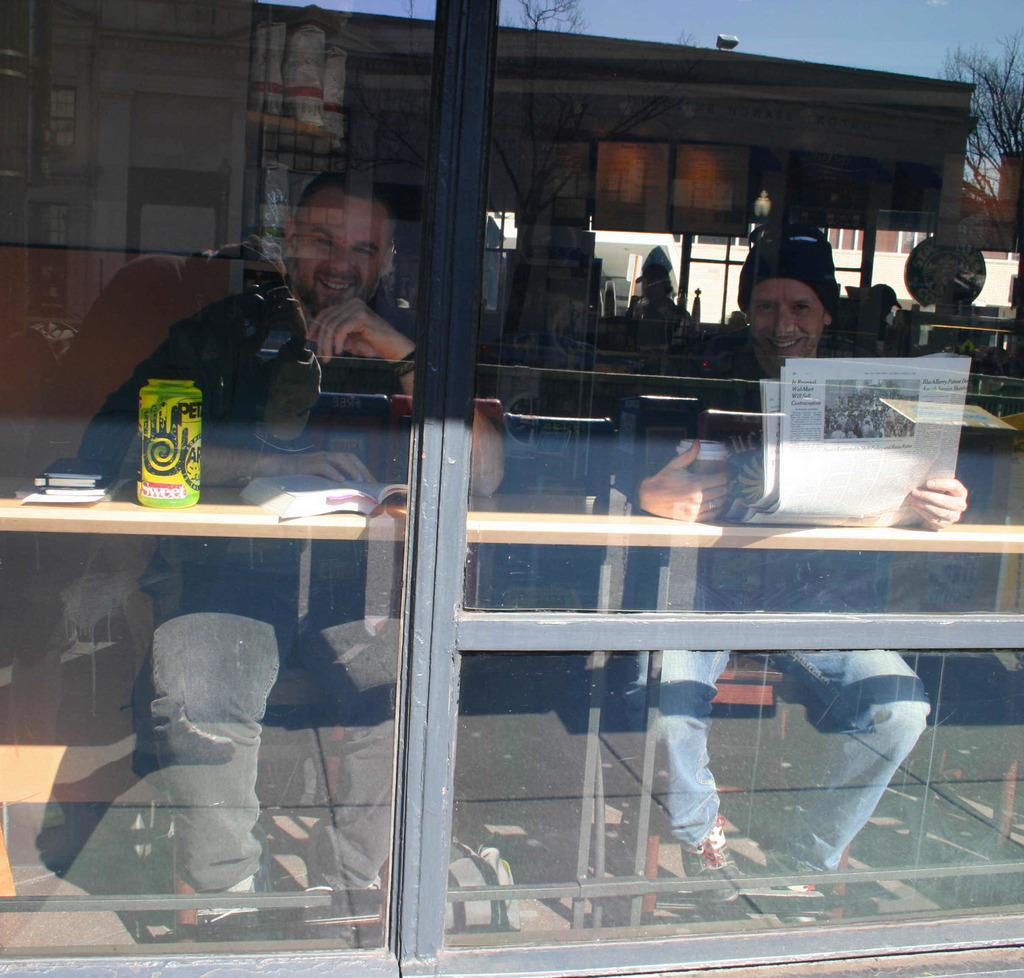How would you summarize this image in a sentence or two? In this picture we can observe a glass. Behind the glass there are two men sitting in front of the table. One of them is holding a paper in his hand. We can observe a cup on the table. Both of them are smiling. In the background we can observe a building, trees and a sky. 